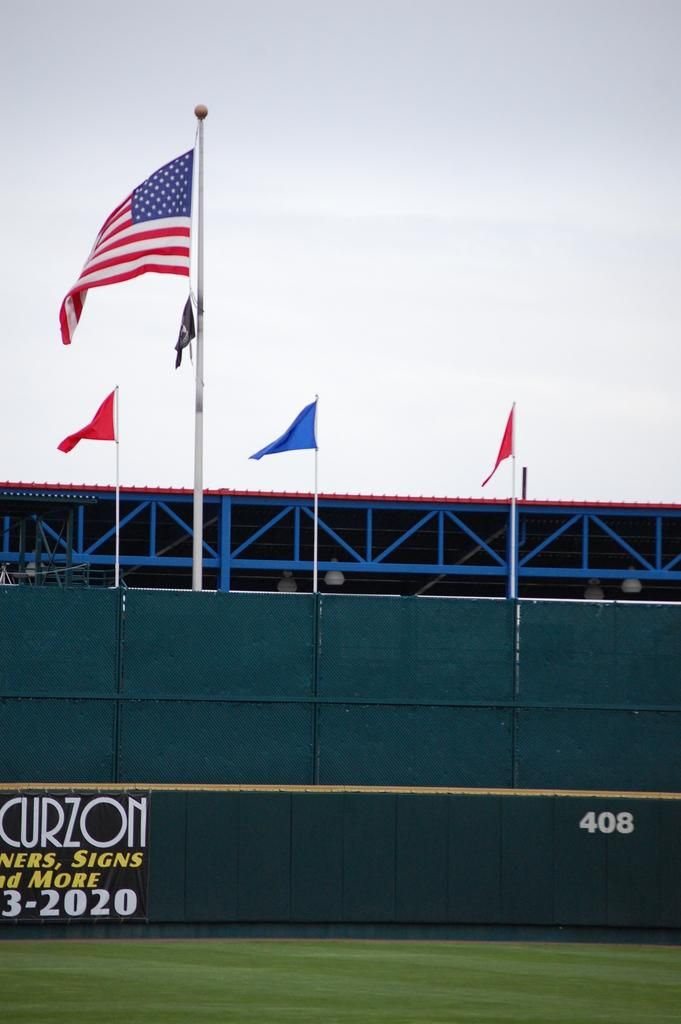What is at the bottom of the image? There is a ground at the bottom of the image. What type of fence can be seen in the image? There is a blue color fence in the image. What is attached to the top of the fence? Flags are present at the top of the fence. What is visible at the top of the image? The sky is visible at the top of the image. What type of ink is used to color the bottle in the image? There is no bottle present in the image, so it is not possible to determine the type of ink used to color it. 